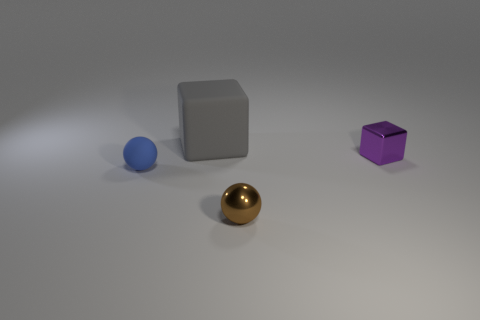There is a cube to the left of the ball right of the gray cube; what is its size?
Your answer should be very brief. Large. Does the block that is to the right of the small brown sphere have the same material as the tiny blue thing?
Offer a very short reply. No. There is a rubber thing on the right side of the small matte thing; what is its shape?
Give a very brief answer. Cube. What number of gray cylinders are the same size as the brown metallic ball?
Ensure brevity in your answer.  0. What size is the gray matte cube?
Your answer should be very brief. Large. How many large gray things are in front of the brown shiny ball?
Provide a succinct answer. 0. What is the shape of the other object that is made of the same material as the big gray object?
Your answer should be very brief. Sphere. Is the number of blue matte balls that are to the left of the tiny blue thing less than the number of matte objects behind the small purple metallic block?
Give a very brief answer. Yes. Are there more small blue matte balls than tiny cyan rubber cylinders?
Give a very brief answer. Yes. What is the material of the small brown sphere?
Provide a short and direct response. Metal. 